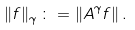Convert formula to latex. <formula><loc_0><loc_0><loc_500><loc_500>\left \| f \right \| _ { \gamma } \colon = \left \| A ^ { \gamma } f \right \| .</formula> 